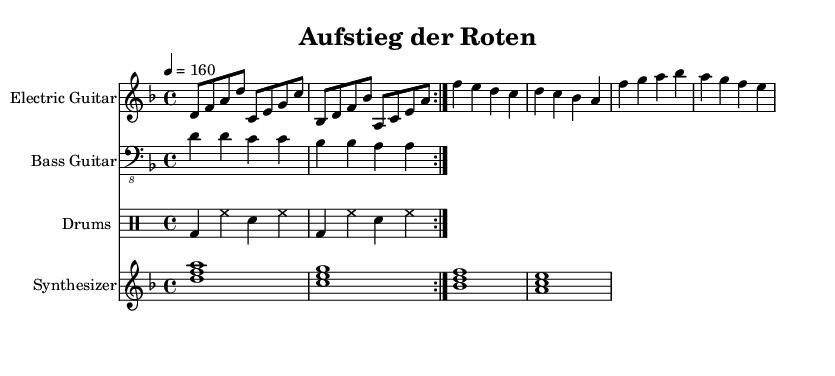What is the key signature of this music? The key signature is indicated at the beginning of the staff lines and shows one flat (B flat), which corresponds to the key of D minor.
Answer: D minor What is the time signature? The time signature shown at the beginning of the music is indicated with two numbers, where the top number is 4 and the bottom number is also 4, meaning there are four beats in each measure and the quarter note gets one beat.
Answer: 4/4 What is the tempo marking for this piece? The tempo marking appears above the staff, specifying the speed of the piece at 160 beats per minute, which is indicated by a quarter note equaling 160.
Answer: 160 How many times is the main riff repeated? The main riff is marked with a repeat sign, which indicates it should be played two times, as shown in the measure with a repeat volta indicating the repetition.
Answer: 2 What is the highest note played in the electric guitar part? The highest note is shown as F in the fourth octave, which can be found in the chorus section of the electric guitar part.
Answer: F What kind of rhythm is primarily used in the drums section? The drums part predominantly features a steady rhythm consisting of bass drums and snare hits on the beats in a repetitive loop, creating a driving rhythm typical for metal music.
Answer: Steady What instrument is playing the chord progression? The instrument responsible for the chord progression is the synthesizer, indicated at the beginning of the staff which shows the use of chords like D minor, C major, B flat major, and A major.
Answer: Synthesizer 